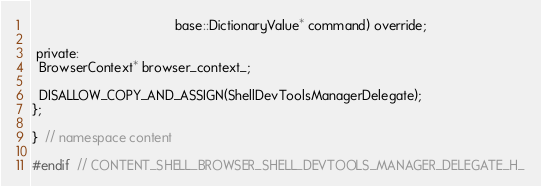Convert code to text. <code><loc_0><loc_0><loc_500><loc_500><_C_>                                       base::DictionaryValue* command) override;

 private:
  BrowserContext* browser_context_;

  DISALLOW_COPY_AND_ASSIGN(ShellDevToolsManagerDelegate);
};

}  // namespace content

#endif  // CONTENT_SHELL_BROWSER_SHELL_DEVTOOLS_MANAGER_DELEGATE_H_
</code> 